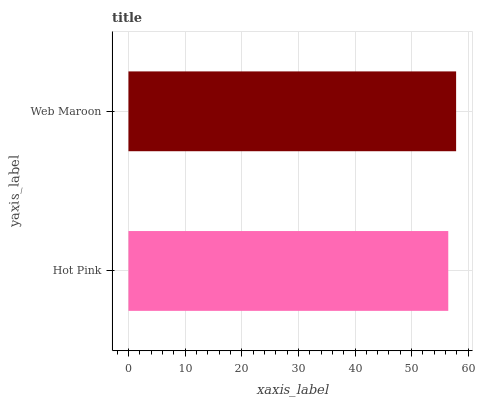Is Hot Pink the minimum?
Answer yes or no. Yes. Is Web Maroon the maximum?
Answer yes or no. Yes. Is Web Maroon the minimum?
Answer yes or no. No. Is Web Maroon greater than Hot Pink?
Answer yes or no. Yes. Is Hot Pink less than Web Maroon?
Answer yes or no. Yes. Is Hot Pink greater than Web Maroon?
Answer yes or no. No. Is Web Maroon less than Hot Pink?
Answer yes or no. No. Is Web Maroon the high median?
Answer yes or no. Yes. Is Hot Pink the low median?
Answer yes or no. Yes. Is Hot Pink the high median?
Answer yes or no. No. Is Web Maroon the low median?
Answer yes or no. No. 